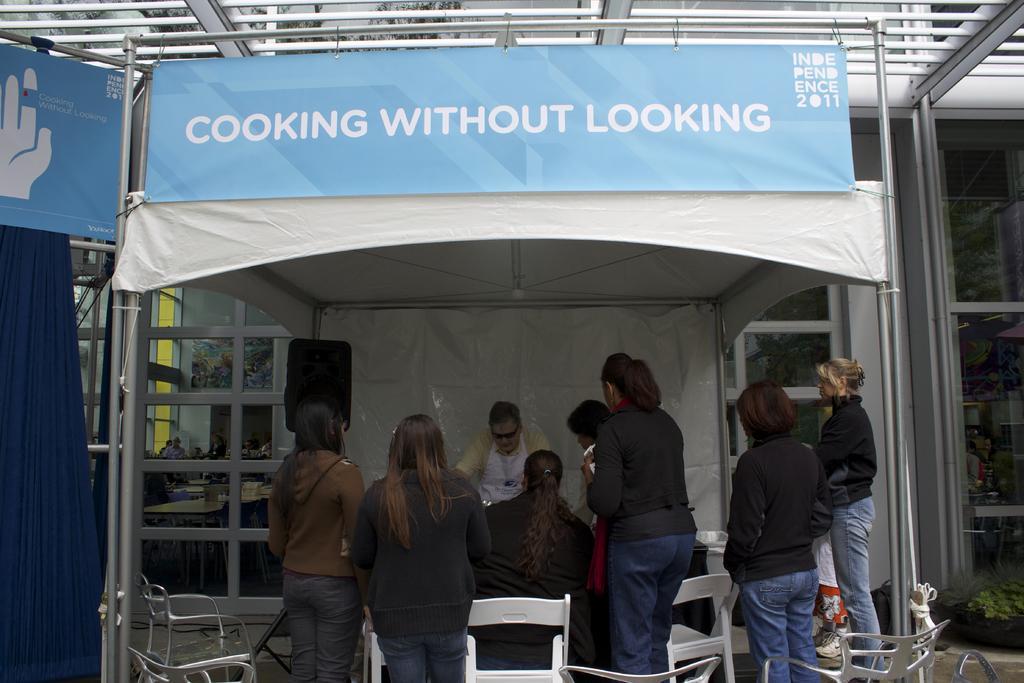Please provide a concise description of this image. In this picture there are six ladies wearing black color t-shirt and standing. In front of them there is a man standing. On top of them there is a tent. And to the left side there is a speaker. And in the top we can see a poster. In the background there are glass windows. And to the left side there is a blue color curtain. 